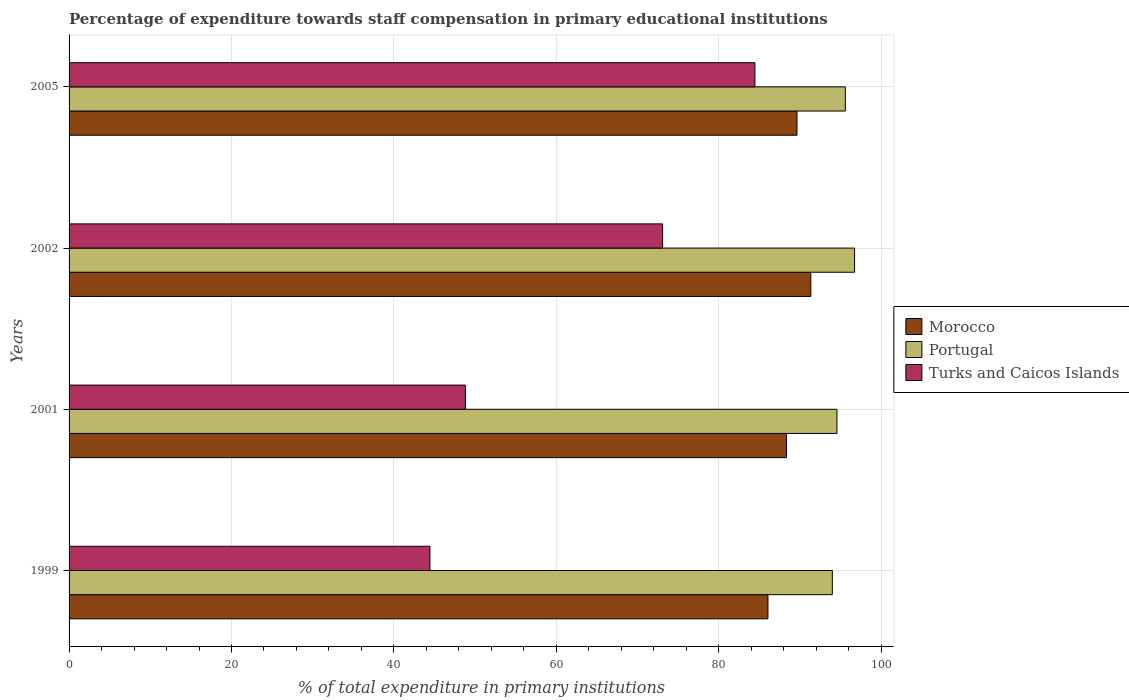How many groups of bars are there?
Make the answer very short. 4. Are the number of bars per tick equal to the number of legend labels?
Offer a very short reply. Yes. How many bars are there on the 2nd tick from the top?
Your answer should be very brief. 3. What is the label of the 1st group of bars from the top?
Provide a succinct answer. 2005. In how many cases, is the number of bars for a given year not equal to the number of legend labels?
Provide a succinct answer. 0. What is the percentage of expenditure towards staff compensation in Turks and Caicos Islands in 2005?
Your response must be concise. 84.46. Across all years, what is the maximum percentage of expenditure towards staff compensation in Morocco?
Offer a very short reply. 91.35. Across all years, what is the minimum percentage of expenditure towards staff compensation in Turks and Caicos Islands?
Offer a terse response. 44.44. In which year was the percentage of expenditure towards staff compensation in Turks and Caicos Islands maximum?
Provide a succinct answer. 2005. What is the total percentage of expenditure towards staff compensation in Portugal in the graph?
Provide a short and direct response. 380.88. What is the difference between the percentage of expenditure towards staff compensation in Turks and Caicos Islands in 1999 and that in 2002?
Your response must be concise. -28.66. What is the difference between the percentage of expenditure towards staff compensation in Morocco in 1999 and the percentage of expenditure towards staff compensation in Portugal in 2002?
Your answer should be compact. -10.67. What is the average percentage of expenditure towards staff compensation in Turks and Caicos Islands per year?
Offer a very short reply. 62.7. In the year 1999, what is the difference between the percentage of expenditure towards staff compensation in Morocco and percentage of expenditure towards staff compensation in Portugal?
Offer a very short reply. -7.93. What is the ratio of the percentage of expenditure towards staff compensation in Portugal in 1999 to that in 2005?
Your answer should be very brief. 0.98. What is the difference between the highest and the second highest percentage of expenditure towards staff compensation in Portugal?
Your response must be concise. 1.14. What is the difference between the highest and the lowest percentage of expenditure towards staff compensation in Turks and Caicos Islands?
Provide a short and direct response. 40.02. In how many years, is the percentage of expenditure towards staff compensation in Portugal greater than the average percentage of expenditure towards staff compensation in Portugal taken over all years?
Your answer should be very brief. 2. Is the sum of the percentage of expenditure towards staff compensation in Portugal in 2001 and 2005 greater than the maximum percentage of expenditure towards staff compensation in Turks and Caicos Islands across all years?
Your answer should be very brief. Yes. What does the 3rd bar from the bottom in 2001 represents?
Provide a succinct answer. Turks and Caicos Islands. Is it the case that in every year, the sum of the percentage of expenditure towards staff compensation in Portugal and percentage of expenditure towards staff compensation in Morocco is greater than the percentage of expenditure towards staff compensation in Turks and Caicos Islands?
Give a very brief answer. Yes. What is the difference between two consecutive major ticks on the X-axis?
Your answer should be very brief. 20. Are the values on the major ticks of X-axis written in scientific E-notation?
Your answer should be very brief. No. How many legend labels are there?
Your response must be concise. 3. How are the legend labels stacked?
Ensure brevity in your answer.  Vertical. What is the title of the graph?
Your answer should be compact. Percentage of expenditure towards staff compensation in primary educational institutions. Does "Aruba" appear as one of the legend labels in the graph?
Make the answer very short. No. What is the label or title of the X-axis?
Provide a succinct answer. % of total expenditure in primary institutions. What is the % of total expenditure in primary institutions in Morocco in 1999?
Offer a terse response. 86.07. What is the % of total expenditure in primary institutions in Portugal in 1999?
Your response must be concise. 93.99. What is the % of total expenditure in primary institutions of Turks and Caicos Islands in 1999?
Make the answer very short. 44.44. What is the % of total expenditure in primary institutions of Morocco in 2001?
Give a very brief answer. 88.34. What is the % of total expenditure in primary institutions in Portugal in 2001?
Keep it short and to the point. 94.56. What is the % of total expenditure in primary institutions of Turks and Caicos Islands in 2001?
Offer a terse response. 48.8. What is the % of total expenditure in primary institutions of Morocco in 2002?
Make the answer very short. 91.35. What is the % of total expenditure in primary institutions of Portugal in 2002?
Your answer should be compact. 96.73. What is the % of total expenditure in primary institutions of Turks and Caicos Islands in 2002?
Make the answer very short. 73.09. What is the % of total expenditure in primary institutions in Morocco in 2005?
Keep it short and to the point. 89.64. What is the % of total expenditure in primary institutions in Portugal in 2005?
Offer a terse response. 95.6. What is the % of total expenditure in primary institutions in Turks and Caicos Islands in 2005?
Offer a terse response. 84.46. Across all years, what is the maximum % of total expenditure in primary institutions of Morocco?
Provide a succinct answer. 91.35. Across all years, what is the maximum % of total expenditure in primary institutions of Portugal?
Your answer should be compact. 96.73. Across all years, what is the maximum % of total expenditure in primary institutions in Turks and Caicos Islands?
Your answer should be very brief. 84.46. Across all years, what is the minimum % of total expenditure in primary institutions in Morocco?
Offer a terse response. 86.07. Across all years, what is the minimum % of total expenditure in primary institutions in Portugal?
Your answer should be very brief. 93.99. Across all years, what is the minimum % of total expenditure in primary institutions in Turks and Caicos Islands?
Offer a terse response. 44.44. What is the total % of total expenditure in primary institutions in Morocco in the graph?
Offer a very short reply. 355.39. What is the total % of total expenditure in primary institutions of Portugal in the graph?
Offer a terse response. 380.88. What is the total % of total expenditure in primary institutions of Turks and Caicos Islands in the graph?
Make the answer very short. 250.79. What is the difference between the % of total expenditure in primary institutions of Morocco in 1999 and that in 2001?
Your response must be concise. -2.27. What is the difference between the % of total expenditure in primary institutions of Portugal in 1999 and that in 2001?
Provide a short and direct response. -0.57. What is the difference between the % of total expenditure in primary institutions of Turks and Caicos Islands in 1999 and that in 2001?
Keep it short and to the point. -4.37. What is the difference between the % of total expenditure in primary institutions of Morocco in 1999 and that in 2002?
Keep it short and to the point. -5.28. What is the difference between the % of total expenditure in primary institutions in Portugal in 1999 and that in 2002?
Ensure brevity in your answer.  -2.74. What is the difference between the % of total expenditure in primary institutions in Turks and Caicos Islands in 1999 and that in 2002?
Ensure brevity in your answer.  -28.66. What is the difference between the % of total expenditure in primary institutions of Morocco in 1999 and that in 2005?
Keep it short and to the point. -3.57. What is the difference between the % of total expenditure in primary institutions of Portugal in 1999 and that in 2005?
Your answer should be compact. -1.6. What is the difference between the % of total expenditure in primary institutions in Turks and Caicos Islands in 1999 and that in 2005?
Your answer should be compact. -40.02. What is the difference between the % of total expenditure in primary institutions in Morocco in 2001 and that in 2002?
Your response must be concise. -3.01. What is the difference between the % of total expenditure in primary institutions of Portugal in 2001 and that in 2002?
Provide a short and direct response. -2.17. What is the difference between the % of total expenditure in primary institutions of Turks and Caicos Islands in 2001 and that in 2002?
Provide a short and direct response. -24.29. What is the difference between the % of total expenditure in primary institutions of Morocco in 2001 and that in 2005?
Your response must be concise. -1.3. What is the difference between the % of total expenditure in primary institutions of Portugal in 2001 and that in 2005?
Keep it short and to the point. -1.03. What is the difference between the % of total expenditure in primary institutions of Turks and Caicos Islands in 2001 and that in 2005?
Keep it short and to the point. -35.65. What is the difference between the % of total expenditure in primary institutions in Morocco in 2002 and that in 2005?
Your response must be concise. 1.71. What is the difference between the % of total expenditure in primary institutions of Portugal in 2002 and that in 2005?
Give a very brief answer. 1.14. What is the difference between the % of total expenditure in primary institutions of Turks and Caicos Islands in 2002 and that in 2005?
Provide a short and direct response. -11.37. What is the difference between the % of total expenditure in primary institutions of Morocco in 1999 and the % of total expenditure in primary institutions of Portugal in 2001?
Provide a succinct answer. -8.5. What is the difference between the % of total expenditure in primary institutions in Morocco in 1999 and the % of total expenditure in primary institutions in Turks and Caicos Islands in 2001?
Your response must be concise. 37.26. What is the difference between the % of total expenditure in primary institutions of Portugal in 1999 and the % of total expenditure in primary institutions of Turks and Caicos Islands in 2001?
Offer a very short reply. 45.19. What is the difference between the % of total expenditure in primary institutions of Morocco in 1999 and the % of total expenditure in primary institutions of Portugal in 2002?
Offer a very short reply. -10.67. What is the difference between the % of total expenditure in primary institutions in Morocco in 1999 and the % of total expenditure in primary institutions in Turks and Caicos Islands in 2002?
Your response must be concise. 12.97. What is the difference between the % of total expenditure in primary institutions in Portugal in 1999 and the % of total expenditure in primary institutions in Turks and Caicos Islands in 2002?
Your response must be concise. 20.9. What is the difference between the % of total expenditure in primary institutions of Morocco in 1999 and the % of total expenditure in primary institutions of Portugal in 2005?
Offer a very short reply. -9.53. What is the difference between the % of total expenditure in primary institutions of Morocco in 1999 and the % of total expenditure in primary institutions of Turks and Caicos Islands in 2005?
Ensure brevity in your answer.  1.61. What is the difference between the % of total expenditure in primary institutions of Portugal in 1999 and the % of total expenditure in primary institutions of Turks and Caicos Islands in 2005?
Your answer should be compact. 9.53. What is the difference between the % of total expenditure in primary institutions of Morocco in 2001 and the % of total expenditure in primary institutions of Portugal in 2002?
Keep it short and to the point. -8.39. What is the difference between the % of total expenditure in primary institutions in Morocco in 2001 and the % of total expenditure in primary institutions in Turks and Caicos Islands in 2002?
Your answer should be very brief. 15.25. What is the difference between the % of total expenditure in primary institutions of Portugal in 2001 and the % of total expenditure in primary institutions of Turks and Caicos Islands in 2002?
Make the answer very short. 21.47. What is the difference between the % of total expenditure in primary institutions of Morocco in 2001 and the % of total expenditure in primary institutions of Portugal in 2005?
Your answer should be compact. -7.26. What is the difference between the % of total expenditure in primary institutions in Morocco in 2001 and the % of total expenditure in primary institutions in Turks and Caicos Islands in 2005?
Your answer should be very brief. 3.88. What is the difference between the % of total expenditure in primary institutions of Portugal in 2001 and the % of total expenditure in primary institutions of Turks and Caicos Islands in 2005?
Offer a very short reply. 10.1. What is the difference between the % of total expenditure in primary institutions of Morocco in 2002 and the % of total expenditure in primary institutions of Portugal in 2005?
Offer a terse response. -4.25. What is the difference between the % of total expenditure in primary institutions of Morocco in 2002 and the % of total expenditure in primary institutions of Turks and Caicos Islands in 2005?
Your response must be concise. 6.89. What is the difference between the % of total expenditure in primary institutions of Portugal in 2002 and the % of total expenditure in primary institutions of Turks and Caicos Islands in 2005?
Give a very brief answer. 12.27. What is the average % of total expenditure in primary institutions in Morocco per year?
Keep it short and to the point. 88.85. What is the average % of total expenditure in primary institutions in Portugal per year?
Offer a terse response. 95.22. What is the average % of total expenditure in primary institutions in Turks and Caicos Islands per year?
Your answer should be very brief. 62.7. In the year 1999, what is the difference between the % of total expenditure in primary institutions of Morocco and % of total expenditure in primary institutions of Portugal?
Give a very brief answer. -7.93. In the year 1999, what is the difference between the % of total expenditure in primary institutions of Morocco and % of total expenditure in primary institutions of Turks and Caicos Islands?
Your response must be concise. 41.63. In the year 1999, what is the difference between the % of total expenditure in primary institutions in Portugal and % of total expenditure in primary institutions in Turks and Caicos Islands?
Offer a very short reply. 49.56. In the year 2001, what is the difference between the % of total expenditure in primary institutions of Morocco and % of total expenditure in primary institutions of Portugal?
Ensure brevity in your answer.  -6.22. In the year 2001, what is the difference between the % of total expenditure in primary institutions of Morocco and % of total expenditure in primary institutions of Turks and Caicos Islands?
Your answer should be compact. 39.54. In the year 2001, what is the difference between the % of total expenditure in primary institutions in Portugal and % of total expenditure in primary institutions in Turks and Caicos Islands?
Give a very brief answer. 45.76. In the year 2002, what is the difference between the % of total expenditure in primary institutions in Morocco and % of total expenditure in primary institutions in Portugal?
Your answer should be compact. -5.39. In the year 2002, what is the difference between the % of total expenditure in primary institutions of Morocco and % of total expenditure in primary institutions of Turks and Caicos Islands?
Your answer should be compact. 18.25. In the year 2002, what is the difference between the % of total expenditure in primary institutions in Portugal and % of total expenditure in primary institutions in Turks and Caicos Islands?
Provide a succinct answer. 23.64. In the year 2005, what is the difference between the % of total expenditure in primary institutions of Morocco and % of total expenditure in primary institutions of Portugal?
Ensure brevity in your answer.  -5.96. In the year 2005, what is the difference between the % of total expenditure in primary institutions of Morocco and % of total expenditure in primary institutions of Turks and Caicos Islands?
Provide a short and direct response. 5.18. In the year 2005, what is the difference between the % of total expenditure in primary institutions in Portugal and % of total expenditure in primary institutions in Turks and Caicos Islands?
Keep it short and to the point. 11.14. What is the ratio of the % of total expenditure in primary institutions in Morocco in 1999 to that in 2001?
Ensure brevity in your answer.  0.97. What is the ratio of the % of total expenditure in primary institutions of Portugal in 1999 to that in 2001?
Offer a very short reply. 0.99. What is the ratio of the % of total expenditure in primary institutions of Turks and Caicos Islands in 1999 to that in 2001?
Your response must be concise. 0.91. What is the ratio of the % of total expenditure in primary institutions in Morocco in 1999 to that in 2002?
Ensure brevity in your answer.  0.94. What is the ratio of the % of total expenditure in primary institutions in Portugal in 1999 to that in 2002?
Provide a succinct answer. 0.97. What is the ratio of the % of total expenditure in primary institutions of Turks and Caicos Islands in 1999 to that in 2002?
Offer a very short reply. 0.61. What is the ratio of the % of total expenditure in primary institutions of Morocco in 1999 to that in 2005?
Your response must be concise. 0.96. What is the ratio of the % of total expenditure in primary institutions of Portugal in 1999 to that in 2005?
Offer a very short reply. 0.98. What is the ratio of the % of total expenditure in primary institutions of Turks and Caicos Islands in 1999 to that in 2005?
Ensure brevity in your answer.  0.53. What is the ratio of the % of total expenditure in primary institutions of Morocco in 2001 to that in 2002?
Make the answer very short. 0.97. What is the ratio of the % of total expenditure in primary institutions of Portugal in 2001 to that in 2002?
Offer a very short reply. 0.98. What is the ratio of the % of total expenditure in primary institutions in Turks and Caicos Islands in 2001 to that in 2002?
Your answer should be compact. 0.67. What is the ratio of the % of total expenditure in primary institutions in Morocco in 2001 to that in 2005?
Offer a very short reply. 0.99. What is the ratio of the % of total expenditure in primary institutions of Turks and Caicos Islands in 2001 to that in 2005?
Make the answer very short. 0.58. What is the ratio of the % of total expenditure in primary institutions of Portugal in 2002 to that in 2005?
Provide a short and direct response. 1.01. What is the ratio of the % of total expenditure in primary institutions of Turks and Caicos Islands in 2002 to that in 2005?
Provide a succinct answer. 0.87. What is the difference between the highest and the second highest % of total expenditure in primary institutions of Morocco?
Provide a short and direct response. 1.71. What is the difference between the highest and the second highest % of total expenditure in primary institutions of Portugal?
Your answer should be compact. 1.14. What is the difference between the highest and the second highest % of total expenditure in primary institutions of Turks and Caicos Islands?
Offer a terse response. 11.37. What is the difference between the highest and the lowest % of total expenditure in primary institutions in Morocco?
Your answer should be very brief. 5.28. What is the difference between the highest and the lowest % of total expenditure in primary institutions of Portugal?
Your answer should be compact. 2.74. What is the difference between the highest and the lowest % of total expenditure in primary institutions in Turks and Caicos Islands?
Your response must be concise. 40.02. 